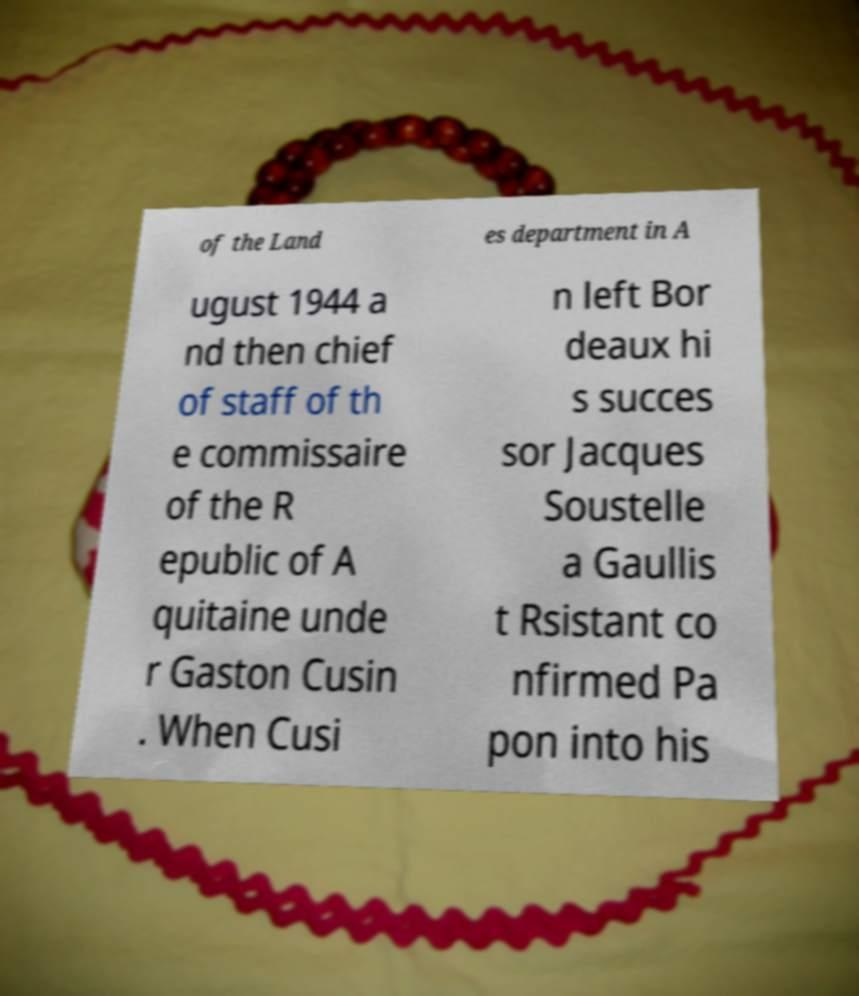There's text embedded in this image that I need extracted. Can you transcribe it verbatim? of the Land es department in A ugust 1944 a nd then chief of staff of th e commissaire of the R epublic of A quitaine unde r Gaston Cusin . When Cusi n left Bor deaux hi s succes sor Jacques Soustelle a Gaullis t Rsistant co nfirmed Pa pon into his 